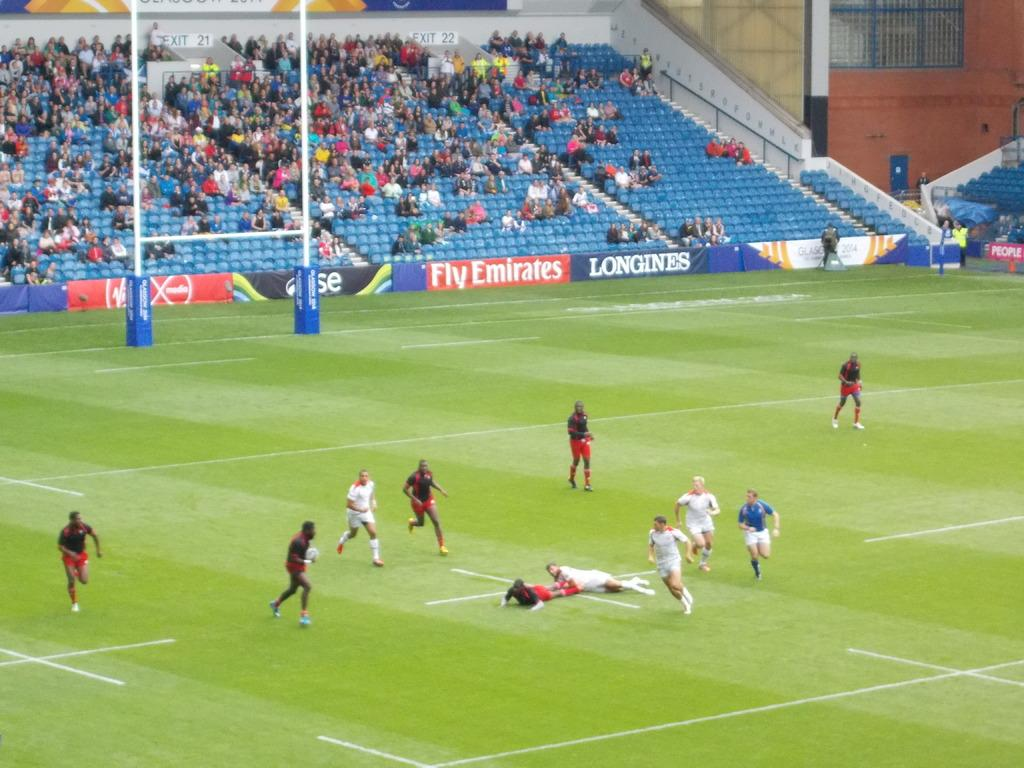<image>
Summarize the visual content of the image. a soccer field with banners that say fly emirates 